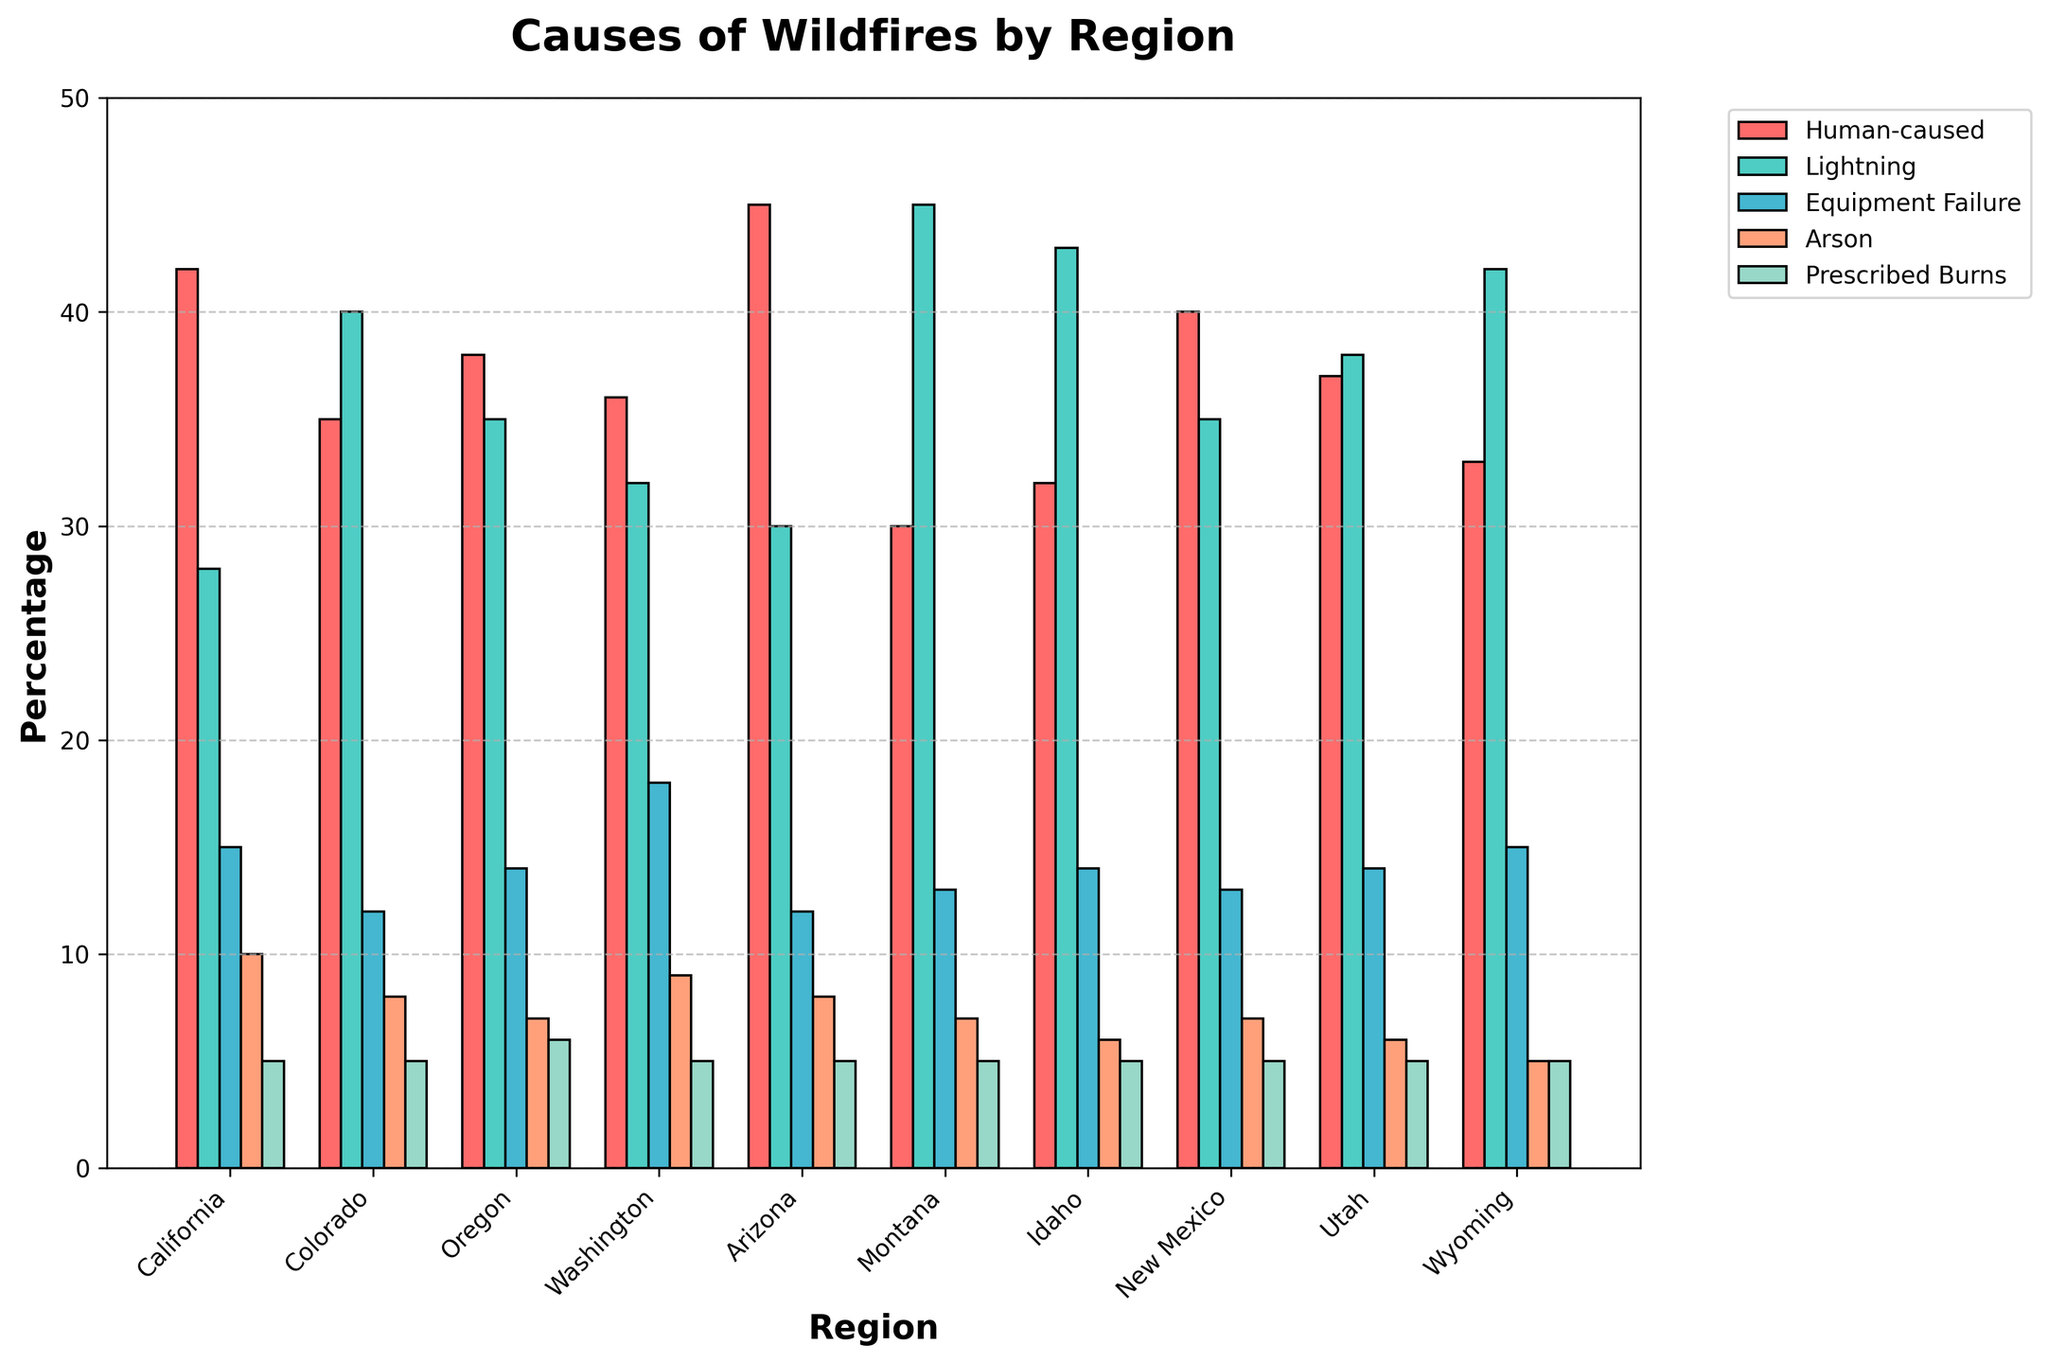What region has the highest percentage of wildfires caused by human activities? We need to scan the "Human-caused" bar for each region and identify the tallest bar. The tallest "Human-caused" bar is in Arizona at 45%.
Answer: Arizona Which cause of wildfires is the most common in Montana? We compare the height of the bars for Montana. The tallest bar in Montana is for "Lightning," indicating that it is the most common cause at 45%.
Answer: Lightning In which regions are wildfires caused by equipment failure higher than 15%? We need to look at the "Equipment Failure" bars and identify those regions where this bar is taller than the value of 15%. Only Washington and Wyoming meet this criterion with 18% and 15%, respectively.
Answer: Washington, Wyoming What is the total percentage of wildfires caused by arson across California, Oregon, and New Mexico? Sum the values of wildfires caused by arson for California (10%), Oregon (7%), and New Mexico (7%). So, 10 + 7 + 7 = 24%.
Answer: 24% Which region has the smallest percentage of wildfires caused by human activities and what is that percentage? Compare the "Human-caused" bars for the smallest one. Montana has the smallest percentage at 30%.
Answer: Montana, 30% Are wildfires caused by prescribed burns consistent across all regions? Examine the "Prescribed Burns" bars for all regions. All regions have a "Prescribed Burns" value of 5%, indicating consistency.
Answer: Yes Which regions have more wildfires caused by lightning than by human activities? For each region, compare the "Lightning" bar with the "Human-caused" bar and identify where "Lightning" is greater. Colorado, Montana, Idaho, and Wyoming have more wildfires caused by lightning than by human activities.
Answer: Colorado, Montana, Idaho, Wyoming What is the average percentage of wildfires caused by equipment failure across all regions? Sum the values of "Equipment Failure" for all regions and divide by the number of regions. Specifically, (15 + 12 + 14 + 18 + 12 + 13 + 14 + 13 + 14 + 15) / 10 = 14.
Answer: 14 Which cause of wildfires has the most even distribution across all regions? We need to estimate the consistency in the height of bars for each cause. "Prescribed Burns" has the same value (5%) across all regions indicating an even distribution.
Answer: Prescribed Burns 